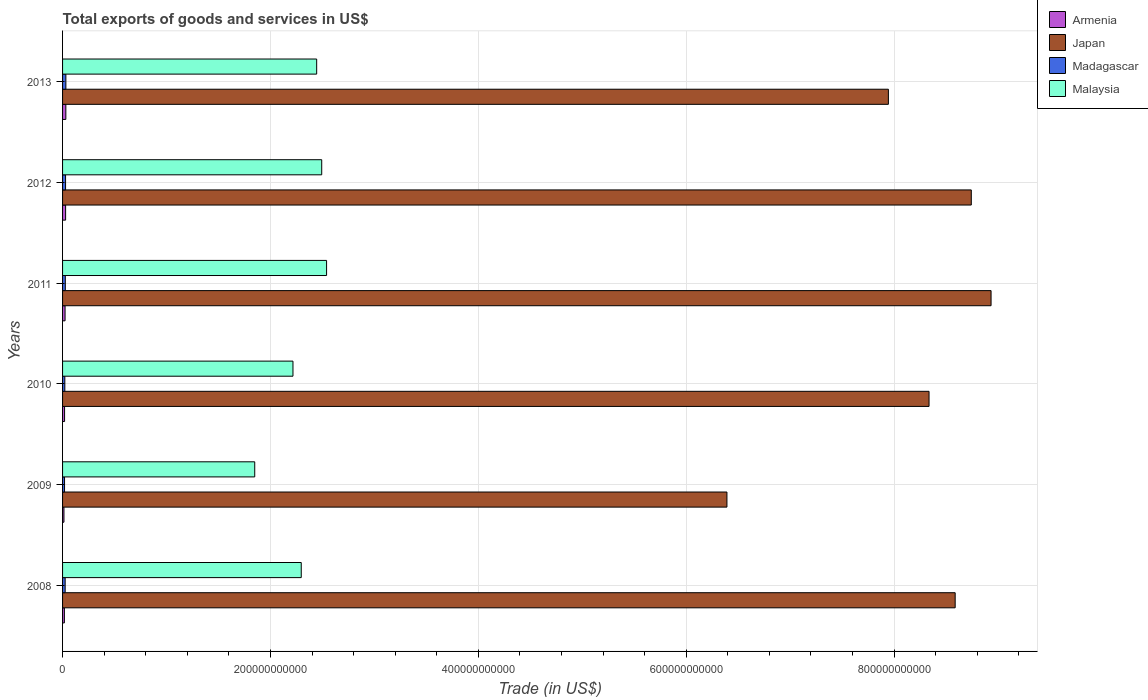How many different coloured bars are there?
Make the answer very short. 4. How many groups of bars are there?
Give a very brief answer. 6. Are the number of bars per tick equal to the number of legend labels?
Your response must be concise. Yes. How many bars are there on the 3rd tick from the top?
Offer a very short reply. 4. In how many cases, is the number of bars for a given year not equal to the number of legend labels?
Ensure brevity in your answer.  0. What is the total exports of goods and services in Malaysia in 2013?
Your answer should be compact. 2.44e+11. Across all years, what is the maximum total exports of goods and services in Armenia?
Ensure brevity in your answer.  3.15e+09. Across all years, what is the minimum total exports of goods and services in Malaysia?
Offer a terse response. 1.85e+11. In which year was the total exports of goods and services in Madagascar maximum?
Your answer should be very brief. 2013. In which year was the total exports of goods and services in Malaysia minimum?
Offer a terse response. 2009. What is the total total exports of goods and services in Malaysia in the graph?
Ensure brevity in your answer.  1.38e+12. What is the difference between the total exports of goods and services in Madagascar in 2008 and that in 2009?
Provide a short and direct response. 5.86e+08. What is the difference between the total exports of goods and services in Armenia in 2010 and the total exports of goods and services in Madagascar in 2011?
Provide a short and direct response. -7.17e+08. What is the average total exports of goods and services in Japan per year?
Keep it short and to the point. 8.16e+11. In the year 2008, what is the difference between the total exports of goods and services in Armenia and total exports of goods and services in Madagascar?
Make the answer very short. -7.44e+08. What is the ratio of the total exports of goods and services in Malaysia in 2008 to that in 2012?
Give a very brief answer. 0.92. Is the total exports of goods and services in Japan in 2011 less than that in 2013?
Offer a very short reply. No. What is the difference between the highest and the second highest total exports of goods and services in Armenia?
Ensure brevity in your answer.  2.27e+08. What is the difference between the highest and the lowest total exports of goods and services in Madagascar?
Your response must be concise. 1.28e+09. What does the 4th bar from the top in 2010 represents?
Keep it short and to the point. Armenia. What does the 3rd bar from the bottom in 2012 represents?
Provide a short and direct response. Madagascar. What is the difference between two consecutive major ticks on the X-axis?
Provide a short and direct response. 2.00e+11. Are the values on the major ticks of X-axis written in scientific E-notation?
Offer a very short reply. No. Does the graph contain any zero values?
Your answer should be very brief. No. Where does the legend appear in the graph?
Ensure brevity in your answer.  Top right. What is the title of the graph?
Ensure brevity in your answer.  Total exports of goods and services in US$. Does "Turkey" appear as one of the legend labels in the graph?
Make the answer very short. No. What is the label or title of the X-axis?
Offer a terse response. Trade (in US$). What is the label or title of the Y-axis?
Give a very brief answer. Years. What is the Trade (in US$) in Armenia in 2008?
Offer a terse response. 1.75e+09. What is the Trade (in US$) of Japan in 2008?
Your answer should be compact. 8.59e+11. What is the Trade (in US$) in Madagascar in 2008?
Provide a short and direct response. 2.50e+09. What is the Trade (in US$) of Malaysia in 2008?
Give a very brief answer. 2.30e+11. What is the Trade (in US$) of Armenia in 2009?
Your response must be concise. 1.34e+09. What is the Trade (in US$) of Japan in 2009?
Your response must be concise. 6.39e+11. What is the Trade (in US$) of Madagascar in 2009?
Ensure brevity in your answer.  1.91e+09. What is the Trade (in US$) of Malaysia in 2009?
Make the answer very short. 1.85e+11. What is the Trade (in US$) in Armenia in 2010?
Offer a terse response. 1.93e+09. What is the Trade (in US$) of Japan in 2010?
Give a very brief answer. 8.34e+11. What is the Trade (in US$) in Madagascar in 2010?
Provide a succinct answer. 2.18e+09. What is the Trade (in US$) of Malaysia in 2010?
Offer a terse response. 2.22e+11. What is the Trade (in US$) in Armenia in 2011?
Provide a short and direct response. 2.41e+09. What is the Trade (in US$) in Japan in 2011?
Your answer should be compact. 8.93e+11. What is the Trade (in US$) of Madagascar in 2011?
Provide a short and direct response. 2.65e+09. What is the Trade (in US$) of Malaysia in 2011?
Offer a terse response. 2.54e+11. What is the Trade (in US$) in Armenia in 2012?
Your response must be concise. 2.93e+09. What is the Trade (in US$) of Japan in 2012?
Your answer should be very brief. 8.74e+11. What is the Trade (in US$) of Madagascar in 2012?
Give a very brief answer. 2.88e+09. What is the Trade (in US$) in Malaysia in 2012?
Offer a very short reply. 2.49e+11. What is the Trade (in US$) in Armenia in 2013?
Provide a succinct answer. 3.15e+09. What is the Trade (in US$) of Japan in 2013?
Your answer should be very brief. 7.95e+11. What is the Trade (in US$) of Madagascar in 2013?
Make the answer very short. 3.19e+09. What is the Trade (in US$) in Malaysia in 2013?
Make the answer very short. 2.44e+11. Across all years, what is the maximum Trade (in US$) of Armenia?
Your answer should be very brief. 3.15e+09. Across all years, what is the maximum Trade (in US$) of Japan?
Offer a very short reply. 8.93e+11. Across all years, what is the maximum Trade (in US$) in Madagascar?
Make the answer very short. 3.19e+09. Across all years, what is the maximum Trade (in US$) in Malaysia?
Provide a short and direct response. 2.54e+11. Across all years, what is the minimum Trade (in US$) in Armenia?
Your answer should be compact. 1.34e+09. Across all years, what is the minimum Trade (in US$) of Japan?
Offer a very short reply. 6.39e+11. Across all years, what is the minimum Trade (in US$) of Madagascar?
Offer a very short reply. 1.91e+09. Across all years, what is the minimum Trade (in US$) of Malaysia?
Provide a succinct answer. 1.85e+11. What is the total Trade (in US$) in Armenia in the graph?
Give a very brief answer. 1.35e+1. What is the total Trade (in US$) of Japan in the graph?
Offer a terse response. 4.89e+12. What is the total Trade (in US$) in Madagascar in the graph?
Ensure brevity in your answer.  1.53e+1. What is the total Trade (in US$) in Malaysia in the graph?
Keep it short and to the point. 1.38e+12. What is the difference between the Trade (in US$) of Armenia in 2008 and that in 2009?
Provide a short and direct response. 4.17e+08. What is the difference between the Trade (in US$) of Japan in 2008 and that in 2009?
Ensure brevity in your answer.  2.20e+11. What is the difference between the Trade (in US$) in Madagascar in 2008 and that in 2009?
Provide a short and direct response. 5.86e+08. What is the difference between the Trade (in US$) in Malaysia in 2008 and that in 2009?
Give a very brief answer. 4.48e+1. What is the difference between the Trade (in US$) of Armenia in 2008 and that in 2010?
Provide a succinct answer. -1.74e+08. What is the difference between the Trade (in US$) of Japan in 2008 and that in 2010?
Provide a short and direct response. 2.51e+1. What is the difference between the Trade (in US$) of Madagascar in 2008 and that in 2010?
Your answer should be compact. 3.18e+08. What is the difference between the Trade (in US$) of Malaysia in 2008 and that in 2010?
Keep it short and to the point. 7.97e+09. What is the difference between the Trade (in US$) of Armenia in 2008 and that in 2011?
Offer a very short reply. -6.55e+08. What is the difference between the Trade (in US$) in Japan in 2008 and that in 2011?
Offer a terse response. -3.45e+1. What is the difference between the Trade (in US$) in Madagascar in 2008 and that in 2011?
Give a very brief answer. -1.47e+08. What is the difference between the Trade (in US$) of Malaysia in 2008 and that in 2011?
Your answer should be compact. -2.44e+1. What is the difference between the Trade (in US$) in Armenia in 2008 and that in 2012?
Provide a short and direct response. -1.17e+09. What is the difference between the Trade (in US$) of Japan in 2008 and that in 2012?
Your answer should be very brief. -1.55e+1. What is the difference between the Trade (in US$) of Madagascar in 2008 and that in 2012?
Ensure brevity in your answer.  -3.79e+08. What is the difference between the Trade (in US$) in Malaysia in 2008 and that in 2012?
Ensure brevity in your answer.  -1.97e+1. What is the difference between the Trade (in US$) of Armenia in 2008 and that in 2013?
Offer a very short reply. -1.40e+09. What is the difference between the Trade (in US$) of Japan in 2008 and that in 2013?
Provide a succinct answer. 6.43e+1. What is the difference between the Trade (in US$) of Madagascar in 2008 and that in 2013?
Make the answer very short. -6.93e+08. What is the difference between the Trade (in US$) of Malaysia in 2008 and that in 2013?
Make the answer very short. -1.48e+1. What is the difference between the Trade (in US$) of Armenia in 2009 and that in 2010?
Provide a short and direct response. -5.91e+08. What is the difference between the Trade (in US$) of Japan in 2009 and that in 2010?
Provide a succinct answer. -1.94e+11. What is the difference between the Trade (in US$) of Madagascar in 2009 and that in 2010?
Provide a succinct answer. -2.68e+08. What is the difference between the Trade (in US$) of Malaysia in 2009 and that in 2010?
Offer a terse response. -3.68e+1. What is the difference between the Trade (in US$) of Armenia in 2009 and that in 2011?
Your answer should be very brief. -1.07e+09. What is the difference between the Trade (in US$) of Japan in 2009 and that in 2011?
Offer a terse response. -2.54e+11. What is the difference between the Trade (in US$) in Madagascar in 2009 and that in 2011?
Make the answer very short. -7.33e+08. What is the difference between the Trade (in US$) of Malaysia in 2009 and that in 2011?
Provide a succinct answer. -6.91e+1. What is the difference between the Trade (in US$) in Armenia in 2009 and that in 2012?
Keep it short and to the point. -1.59e+09. What is the difference between the Trade (in US$) in Japan in 2009 and that in 2012?
Offer a terse response. -2.35e+11. What is the difference between the Trade (in US$) of Madagascar in 2009 and that in 2012?
Offer a very short reply. -9.65e+08. What is the difference between the Trade (in US$) of Malaysia in 2009 and that in 2012?
Make the answer very short. -6.45e+1. What is the difference between the Trade (in US$) in Armenia in 2009 and that in 2013?
Provide a short and direct response. -1.82e+09. What is the difference between the Trade (in US$) in Japan in 2009 and that in 2013?
Give a very brief answer. -1.55e+11. What is the difference between the Trade (in US$) in Madagascar in 2009 and that in 2013?
Provide a short and direct response. -1.28e+09. What is the difference between the Trade (in US$) of Malaysia in 2009 and that in 2013?
Offer a terse response. -5.96e+1. What is the difference between the Trade (in US$) in Armenia in 2010 and that in 2011?
Provide a short and direct response. -4.81e+08. What is the difference between the Trade (in US$) in Japan in 2010 and that in 2011?
Your response must be concise. -5.97e+1. What is the difference between the Trade (in US$) of Madagascar in 2010 and that in 2011?
Make the answer very short. -4.65e+08. What is the difference between the Trade (in US$) of Malaysia in 2010 and that in 2011?
Keep it short and to the point. -3.23e+1. What is the difference between the Trade (in US$) of Armenia in 2010 and that in 2012?
Provide a short and direct response. -9.98e+08. What is the difference between the Trade (in US$) of Japan in 2010 and that in 2012?
Give a very brief answer. -4.06e+1. What is the difference between the Trade (in US$) in Madagascar in 2010 and that in 2012?
Offer a terse response. -6.98e+08. What is the difference between the Trade (in US$) in Malaysia in 2010 and that in 2012?
Provide a succinct answer. -2.77e+1. What is the difference between the Trade (in US$) of Armenia in 2010 and that in 2013?
Give a very brief answer. -1.23e+09. What is the difference between the Trade (in US$) in Japan in 2010 and that in 2013?
Provide a succinct answer. 3.91e+1. What is the difference between the Trade (in US$) in Madagascar in 2010 and that in 2013?
Give a very brief answer. -1.01e+09. What is the difference between the Trade (in US$) in Malaysia in 2010 and that in 2013?
Your answer should be very brief. -2.28e+1. What is the difference between the Trade (in US$) of Armenia in 2011 and that in 2012?
Provide a short and direct response. -5.18e+08. What is the difference between the Trade (in US$) in Japan in 2011 and that in 2012?
Provide a short and direct response. 1.90e+1. What is the difference between the Trade (in US$) of Madagascar in 2011 and that in 2012?
Ensure brevity in your answer.  -2.32e+08. What is the difference between the Trade (in US$) of Malaysia in 2011 and that in 2012?
Offer a very short reply. 4.67e+09. What is the difference between the Trade (in US$) of Armenia in 2011 and that in 2013?
Ensure brevity in your answer.  -7.45e+08. What is the difference between the Trade (in US$) of Japan in 2011 and that in 2013?
Your answer should be very brief. 9.88e+1. What is the difference between the Trade (in US$) of Madagascar in 2011 and that in 2013?
Provide a succinct answer. -5.46e+08. What is the difference between the Trade (in US$) in Malaysia in 2011 and that in 2013?
Give a very brief answer. 9.53e+09. What is the difference between the Trade (in US$) of Armenia in 2012 and that in 2013?
Offer a terse response. -2.27e+08. What is the difference between the Trade (in US$) of Japan in 2012 and that in 2013?
Provide a succinct answer. 7.98e+1. What is the difference between the Trade (in US$) of Madagascar in 2012 and that in 2013?
Ensure brevity in your answer.  -3.13e+08. What is the difference between the Trade (in US$) in Malaysia in 2012 and that in 2013?
Ensure brevity in your answer.  4.86e+09. What is the difference between the Trade (in US$) of Armenia in 2008 and the Trade (in US$) of Japan in 2009?
Your answer should be very brief. -6.37e+11. What is the difference between the Trade (in US$) in Armenia in 2008 and the Trade (in US$) in Madagascar in 2009?
Give a very brief answer. -1.58e+08. What is the difference between the Trade (in US$) in Armenia in 2008 and the Trade (in US$) in Malaysia in 2009?
Your answer should be very brief. -1.83e+11. What is the difference between the Trade (in US$) in Japan in 2008 and the Trade (in US$) in Madagascar in 2009?
Make the answer very short. 8.57e+11. What is the difference between the Trade (in US$) in Japan in 2008 and the Trade (in US$) in Malaysia in 2009?
Keep it short and to the point. 6.74e+11. What is the difference between the Trade (in US$) of Madagascar in 2008 and the Trade (in US$) of Malaysia in 2009?
Your answer should be very brief. -1.82e+11. What is the difference between the Trade (in US$) of Armenia in 2008 and the Trade (in US$) of Japan in 2010?
Provide a succinct answer. -8.32e+11. What is the difference between the Trade (in US$) of Armenia in 2008 and the Trade (in US$) of Madagascar in 2010?
Your answer should be compact. -4.25e+08. What is the difference between the Trade (in US$) of Armenia in 2008 and the Trade (in US$) of Malaysia in 2010?
Provide a succinct answer. -2.20e+11. What is the difference between the Trade (in US$) in Japan in 2008 and the Trade (in US$) in Madagascar in 2010?
Your answer should be very brief. 8.57e+11. What is the difference between the Trade (in US$) in Japan in 2008 and the Trade (in US$) in Malaysia in 2010?
Give a very brief answer. 6.37e+11. What is the difference between the Trade (in US$) in Madagascar in 2008 and the Trade (in US$) in Malaysia in 2010?
Your answer should be very brief. -2.19e+11. What is the difference between the Trade (in US$) of Armenia in 2008 and the Trade (in US$) of Japan in 2011?
Your answer should be very brief. -8.92e+11. What is the difference between the Trade (in US$) of Armenia in 2008 and the Trade (in US$) of Madagascar in 2011?
Provide a short and direct response. -8.91e+08. What is the difference between the Trade (in US$) of Armenia in 2008 and the Trade (in US$) of Malaysia in 2011?
Make the answer very short. -2.52e+11. What is the difference between the Trade (in US$) of Japan in 2008 and the Trade (in US$) of Madagascar in 2011?
Provide a succinct answer. 8.56e+11. What is the difference between the Trade (in US$) of Japan in 2008 and the Trade (in US$) of Malaysia in 2011?
Offer a very short reply. 6.05e+11. What is the difference between the Trade (in US$) in Madagascar in 2008 and the Trade (in US$) in Malaysia in 2011?
Make the answer very short. -2.52e+11. What is the difference between the Trade (in US$) in Armenia in 2008 and the Trade (in US$) in Japan in 2012?
Your answer should be compact. -8.73e+11. What is the difference between the Trade (in US$) in Armenia in 2008 and the Trade (in US$) in Madagascar in 2012?
Ensure brevity in your answer.  -1.12e+09. What is the difference between the Trade (in US$) of Armenia in 2008 and the Trade (in US$) of Malaysia in 2012?
Your response must be concise. -2.48e+11. What is the difference between the Trade (in US$) in Japan in 2008 and the Trade (in US$) in Madagascar in 2012?
Provide a succinct answer. 8.56e+11. What is the difference between the Trade (in US$) of Japan in 2008 and the Trade (in US$) of Malaysia in 2012?
Your answer should be very brief. 6.09e+11. What is the difference between the Trade (in US$) of Madagascar in 2008 and the Trade (in US$) of Malaysia in 2012?
Your answer should be compact. -2.47e+11. What is the difference between the Trade (in US$) of Armenia in 2008 and the Trade (in US$) of Japan in 2013?
Offer a very short reply. -7.93e+11. What is the difference between the Trade (in US$) of Armenia in 2008 and the Trade (in US$) of Madagascar in 2013?
Provide a short and direct response. -1.44e+09. What is the difference between the Trade (in US$) in Armenia in 2008 and the Trade (in US$) in Malaysia in 2013?
Make the answer very short. -2.43e+11. What is the difference between the Trade (in US$) in Japan in 2008 and the Trade (in US$) in Madagascar in 2013?
Your answer should be compact. 8.56e+11. What is the difference between the Trade (in US$) of Japan in 2008 and the Trade (in US$) of Malaysia in 2013?
Your answer should be very brief. 6.14e+11. What is the difference between the Trade (in US$) of Madagascar in 2008 and the Trade (in US$) of Malaysia in 2013?
Offer a very short reply. -2.42e+11. What is the difference between the Trade (in US$) of Armenia in 2009 and the Trade (in US$) of Japan in 2010?
Your response must be concise. -8.32e+11. What is the difference between the Trade (in US$) in Armenia in 2009 and the Trade (in US$) in Madagascar in 2010?
Your answer should be compact. -8.42e+08. What is the difference between the Trade (in US$) of Armenia in 2009 and the Trade (in US$) of Malaysia in 2010?
Make the answer very short. -2.20e+11. What is the difference between the Trade (in US$) in Japan in 2009 and the Trade (in US$) in Madagascar in 2010?
Offer a very short reply. 6.37e+11. What is the difference between the Trade (in US$) of Japan in 2009 and the Trade (in US$) of Malaysia in 2010?
Your response must be concise. 4.18e+11. What is the difference between the Trade (in US$) in Madagascar in 2009 and the Trade (in US$) in Malaysia in 2010?
Provide a short and direct response. -2.20e+11. What is the difference between the Trade (in US$) in Armenia in 2009 and the Trade (in US$) in Japan in 2011?
Provide a succinct answer. -8.92e+11. What is the difference between the Trade (in US$) of Armenia in 2009 and the Trade (in US$) of Madagascar in 2011?
Ensure brevity in your answer.  -1.31e+09. What is the difference between the Trade (in US$) in Armenia in 2009 and the Trade (in US$) in Malaysia in 2011?
Keep it short and to the point. -2.53e+11. What is the difference between the Trade (in US$) of Japan in 2009 and the Trade (in US$) of Madagascar in 2011?
Offer a very short reply. 6.37e+11. What is the difference between the Trade (in US$) in Japan in 2009 and the Trade (in US$) in Malaysia in 2011?
Offer a terse response. 3.85e+11. What is the difference between the Trade (in US$) in Madagascar in 2009 and the Trade (in US$) in Malaysia in 2011?
Your answer should be very brief. -2.52e+11. What is the difference between the Trade (in US$) in Armenia in 2009 and the Trade (in US$) in Japan in 2012?
Offer a very short reply. -8.73e+11. What is the difference between the Trade (in US$) of Armenia in 2009 and the Trade (in US$) of Madagascar in 2012?
Your answer should be very brief. -1.54e+09. What is the difference between the Trade (in US$) in Armenia in 2009 and the Trade (in US$) in Malaysia in 2012?
Ensure brevity in your answer.  -2.48e+11. What is the difference between the Trade (in US$) of Japan in 2009 and the Trade (in US$) of Madagascar in 2012?
Your response must be concise. 6.36e+11. What is the difference between the Trade (in US$) of Japan in 2009 and the Trade (in US$) of Malaysia in 2012?
Give a very brief answer. 3.90e+11. What is the difference between the Trade (in US$) of Madagascar in 2009 and the Trade (in US$) of Malaysia in 2012?
Offer a very short reply. -2.47e+11. What is the difference between the Trade (in US$) in Armenia in 2009 and the Trade (in US$) in Japan in 2013?
Offer a terse response. -7.93e+11. What is the difference between the Trade (in US$) in Armenia in 2009 and the Trade (in US$) in Madagascar in 2013?
Your response must be concise. -1.85e+09. What is the difference between the Trade (in US$) of Armenia in 2009 and the Trade (in US$) of Malaysia in 2013?
Ensure brevity in your answer.  -2.43e+11. What is the difference between the Trade (in US$) of Japan in 2009 and the Trade (in US$) of Madagascar in 2013?
Provide a succinct answer. 6.36e+11. What is the difference between the Trade (in US$) in Japan in 2009 and the Trade (in US$) in Malaysia in 2013?
Provide a succinct answer. 3.95e+11. What is the difference between the Trade (in US$) of Madagascar in 2009 and the Trade (in US$) of Malaysia in 2013?
Ensure brevity in your answer.  -2.43e+11. What is the difference between the Trade (in US$) of Armenia in 2010 and the Trade (in US$) of Japan in 2011?
Offer a very short reply. -8.91e+11. What is the difference between the Trade (in US$) in Armenia in 2010 and the Trade (in US$) in Madagascar in 2011?
Give a very brief answer. -7.17e+08. What is the difference between the Trade (in US$) in Armenia in 2010 and the Trade (in US$) in Malaysia in 2011?
Offer a terse response. -2.52e+11. What is the difference between the Trade (in US$) of Japan in 2010 and the Trade (in US$) of Madagascar in 2011?
Keep it short and to the point. 8.31e+11. What is the difference between the Trade (in US$) of Japan in 2010 and the Trade (in US$) of Malaysia in 2011?
Your response must be concise. 5.80e+11. What is the difference between the Trade (in US$) of Madagascar in 2010 and the Trade (in US$) of Malaysia in 2011?
Give a very brief answer. -2.52e+11. What is the difference between the Trade (in US$) in Armenia in 2010 and the Trade (in US$) in Japan in 2012?
Make the answer very short. -8.72e+11. What is the difference between the Trade (in US$) of Armenia in 2010 and the Trade (in US$) of Madagascar in 2012?
Provide a succinct answer. -9.49e+08. What is the difference between the Trade (in US$) of Armenia in 2010 and the Trade (in US$) of Malaysia in 2012?
Keep it short and to the point. -2.47e+11. What is the difference between the Trade (in US$) in Japan in 2010 and the Trade (in US$) in Madagascar in 2012?
Offer a terse response. 8.31e+11. What is the difference between the Trade (in US$) in Japan in 2010 and the Trade (in US$) in Malaysia in 2012?
Provide a succinct answer. 5.84e+11. What is the difference between the Trade (in US$) of Madagascar in 2010 and the Trade (in US$) of Malaysia in 2012?
Your answer should be very brief. -2.47e+11. What is the difference between the Trade (in US$) in Armenia in 2010 and the Trade (in US$) in Japan in 2013?
Your response must be concise. -7.93e+11. What is the difference between the Trade (in US$) of Armenia in 2010 and the Trade (in US$) of Madagascar in 2013?
Offer a terse response. -1.26e+09. What is the difference between the Trade (in US$) of Armenia in 2010 and the Trade (in US$) of Malaysia in 2013?
Your response must be concise. -2.43e+11. What is the difference between the Trade (in US$) in Japan in 2010 and the Trade (in US$) in Madagascar in 2013?
Keep it short and to the point. 8.31e+11. What is the difference between the Trade (in US$) of Japan in 2010 and the Trade (in US$) of Malaysia in 2013?
Offer a terse response. 5.89e+11. What is the difference between the Trade (in US$) in Madagascar in 2010 and the Trade (in US$) in Malaysia in 2013?
Make the answer very short. -2.42e+11. What is the difference between the Trade (in US$) of Armenia in 2011 and the Trade (in US$) of Japan in 2012?
Your response must be concise. -8.72e+11. What is the difference between the Trade (in US$) of Armenia in 2011 and the Trade (in US$) of Madagascar in 2012?
Make the answer very short. -4.68e+08. What is the difference between the Trade (in US$) of Armenia in 2011 and the Trade (in US$) of Malaysia in 2012?
Offer a very short reply. -2.47e+11. What is the difference between the Trade (in US$) of Japan in 2011 and the Trade (in US$) of Madagascar in 2012?
Provide a succinct answer. 8.91e+11. What is the difference between the Trade (in US$) in Japan in 2011 and the Trade (in US$) in Malaysia in 2012?
Provide a succinct answer. 6.44e+11. What is the difference between the Trade (in US$) of Madagascar in 2011 and the Trade (in US$) of Malaysia in 2012?
Your answer should be compact. -2.47e+11. What is the difference between the Trade (in US$) of Armenia in 2011 and the Trade (in US$) of Japan in 2013?
Provide a short and direct response. -7.92e+11. What is the difference between the Trade (in US$) of Armenia in 2011 and the Trade (in US$) of Madagascar in 2013?
Provide a succinct answer. -7.82e+08. What is the difference between the Trade (in US$) of Armenia in 2011 and the Trade (in US$) of Malaysia in 2013?
Provide a short and direct response. -2.42e+11. What is the difference between the Trade (in US$) in Japan in 2011 and the Trade (in US$) in Madagascar in 2013?
Give a very brief answer. 8.90e+11. What is the difference between the Trade (in US$) of Japan in 2011 and the Trade (in US$) of Malaysia in 2013?
Offer a very short reply. 6.49e+11. What is the difference between the Trade (in US$) of Madagascar in 2011 and the Trade (in US$) of Malaysia in 2013?
Your answer should be compact. -2.42e+11. What is the difference between the Trade (in US$) of Armenia in 2012 and the Trade (in US$) of Japan in 2013?
Make the answer very short. -7.92e+11. What is the difference between the Trade (in US$) of Armenia in 2012 and the Trade (in US$) of Madagascar in 2013?
Your answer should be compact. -2.64e+08. What is the difference between the Trade (in US$) of Armenia in 2012 and the Trade (in US$) of Malaysia in 2013?
Offer a very short reply. -2.42e+11. What is the difference between the Trade (in US$) in Japan in 2012 and the Trade (in US$) in Madagascar in 2013?
Provide a succinct answer. 8.71e+11. What is the difference between the Trade (in US$) in Japan in 2012 and the Trade (in US$) in Malaysia in 2013?
Give a very brief answer. 6.30e+11. What is the difference between the Trade (in US$) of Madagascar in 2012 and the Trade (in US$) of Malaysia in 2013?
Offer a terse response. -2.42e+11. What is the average Trade (in US$) of Armenia per year?
Keep it short and to the point. 2.25e+09. What is the average Trade (in US$) in Japan per year?
Give a very brief answer. 8.16e+11. What is the average Trade (in US$) in Madagascar per year?
Offer a very short reply. 2.55e+09. What is the average Trade (in US$) in Malaysia per year?
Offer a very short reply. 2.31e+11. In the year 2008, what is the difference between the Trade (in US$) of Armenia and Trade (in US$) of Japan?
Ensure brevity in your answer.  -8.57e+11. In the year 2008, what is the difference between the Trade (in US$) of Armenia and Trade (in US$) of Madagascar?
Keep it short and to the point. -7.44e+08. In the year 2008, what is the difference between the Trade (in US$) in Armenia and Trade (in US$) in Malaysia?
Your answer should be compact. -2.28e+11. In the year 2008, what is the difference between the Trade (in US$) of Japan and Trade (in US$) of Madagascar?
Keep it short and to the point. 8.56e+11. In the year 2008, what is the difference between the Trade (in US$) of Japan and Trade (in US$) of Malaysia?
Give a very brief answer. 6.29e+11. In the year 2008, what is the difference between the Trade (in US$) in Madagascar and Trade (in US$) in Malaysia?
Ensure brevity in your answer.  -2.27e+11. In the year 2009, what is the difference between the Trade (in US$) of Armenia and Trade (in US$) of Japan?
Your answer should be compact. -6.38e+11. In the year 2009, what is the difference between the Trade (in US$) in Armenia and Trade (in US$) in Madagascar?
Give a very brief answer. -5.74e+08. In the year 2009, what is the difference between the Trade (in US$) in Armenia and Trade (in US$) in Malaysia?
Your answer should be very brief. -1.84e+11. In the year 2009, what is the difference between the Trade (in US$) in Japan and Trade (in US$) in Madagascar?
Give a very brief answer. 6.37e+11. In the year 2009, what is the difference between the Trade (in US$) of Japan and Trade (in US$) of Malaysia?
Provide a succinct answer. 4.54e+11. In the year 2009, what is the difference between the Trade (in US$) in Madagascar and Trade (in US$) in Malaysia?
Keep it short and to the point. -1.83e+11. In the year 2010, what is the difference between the Trade (in US$) in Armenia and Trade (in US$) in Japan?
Keep it short and to the point. -8.32e+11. In the year 2010, what is the difference between the Trade (in US$) in Armenia and Trade (in US$) in Madagascar?
Offer a very short reply. -2.51e+08. In the year 2010, what is the difference between the Trade (in US$) of Armenia and Trade (in US$) of Malaysia?
Make the answer very short. -2.20e+11. In the year 2010, what is the difference between the Trade (in US$) of Japan and Trade (in US$) of Madagascar?
Make the answer very short. 8.32e+11. In the year 2010, what is the difference between the Trade (in US$) of Japan and Trade (in US$) of Malaysia?
Offer a very short reply. 6.12e+11. In the year 2010, what is the difference between the Trade (in US$) of Madagascar and Trade (in US$) of Malaysia?
Keep it short and to the point. -2.20e+11. In the year 2011, what is the difference between the Trade (in US$) of Armenia and Trade (in US$) of Japan?
Ensure brevity in your answer.  -8.91e+11. In the year 2011, what is the difference between the Trade (in US$) of Armenia and Trade (in US$) of Madagascar?
Provide a succinct answer. -2.36e+08. In the year 2011, what is the difference between the Trade (in US$) in Armenia and Trade (in US$) in Malaysia?
Keep it short and to the point. -2.52e+11. In the year 2011, what is the difference between the Trade (in US$) of Japan and Trade (in US$) of Madagascar?
Offer a very short reply. 8.91e+11. In the year 2011, what is the difference between the Trade (in US$) of Japan and Trade (in US$) of Malaysia?
Offer a very short reply. 6.39e+11. In the year 2011, what is the difference between the Trade (in US$) of Madagascar and Trade (in US$) of Malaysia?
Ensure brevity in your answer.  -2.51e+11. In the year 2012, what is the difference between the Trade (in US$) of Armenia and Trade (in US$) of Japan?
Give a very brief answer. -8.71e+11. In the year 2012, what is the difference between the Trade (in US$) in Armenia and Trade (in US$) in Madagascar?
Provide a succinct answer. 4.97e+07. In the year 2012, what is the difference between the Trade (in US$) in Armenia and Trade (in US$) in Malaysia?
Provide a succinct answer. -2.46e+11. In the year 2012, what is the difference between the Trade (in US$) in Japan and Trade (in US$) in Madagascar?
Ensure brevity in your answer.  8.71e+11. In the year 2012, what is the difference between the Trade (in US$) of Japan and Trade (in US$) of Malaysia?
Offer a very short reply. 6.25e+11. In the year 2012, what is the difference between the Trade (in US$) of Madagascar and Trade (in US$) of Malaysia?
Your response must be concise. -2.46e+11. In the year 2013, what is the difference between the Trade (in US$) of Armenia and Trade (in US$) of Japan?
Your answer should be very brief. -7.91e+11. In the year 2013, what is the difference between the Trade (in US$) in Armenia and Trade (in US$) in Madagascar?
Give a very brief answer. -3.72e+07. In the year 2013, what is the difference between the Trade (in US$) in Armenia and Trade (in US$) in Malaysia?
Provide a succinct answer. -2.41e+11. In the year 2013, what is the difference between the Trade (in US$) of Japan and Trade (in US$) of Madagascar?
Provide a short and direct response. 7.91e+11. In the year 2013, what is the difference between the Trade (in US$) of Japan and Trade (in US$) of Malaysia?
Give a very brief answer. 5.50e+11. In the year 2013, what is the difference between the Trade (in US$) in Madagascar and Trade (in US$) in Malaysia?
Give a very brief answer. -2.41e+11. What is the ratio of the Trade (in US$) in Armenia in 2008 to that in 2009?
Ensure brevity in your answer.  1.31. What is the ratio of the Trade (in US$) of Japan in 2008 to that in 2009?
Offer a very short reply. 1.34. What is the ratio of the Trade (in US$) in Madagascar in 2008 to that in 2009?
Make the answer very short. 1.31. What is the ratio of the Trade (in US$) of Malaysia in 2008 to that in 2009?
Offer a very short reply. 1.24. What is the ratio of the Trade (in US$) in Armenia in 2008 to that in 2010?
Offer a very short reply. 0.91. What is the ratio of the Trade (in US$) in Japan in 2008 to that in 2010?
Give a very brief answer. 1.03. What is the ratio of the Trade (in US$) in Madagascar in 2008 to that in 2010?
Ensure brevity in your answer.  1.15. What is the ratio of the Trade (in US$) in Malaysia in 2008 to that in 2010?
Make the answer very short. 1.04. What is the ratio of the Trade (in US$) of Armenia in 2008 to that in 2011?
Keep it short and to the point. 0.73. What is the ratio of the Trade (in US$) of Japan in 2008 to that in 2011?
Offer a terse response. 0.96. What is the ratio of the Trade (in US$) of Madagascar in 2008 to that in 2011?
Your answer should be very brief. 0.94. What is the ratio of the Trade (in US$) of Malaysia in 2008 to that in 2011?
Provide a succinct answer. 0.9. What is the ratio of the Trade (in US$) in Armenia in 2008 to that in 2012?
Ensure brevity in your answer.  0.6. What is the ratio of the Trade (in US$) in Japan in 2008 to that in 2012?
Make the answer very short. 0.98. What is the ratio of the Trade (in US$) in Madagascar in 2008 to that in 2012?
Make the answer very short. 0.87. What is the ratio of the Trade (in US$) of Malaysia in 2008 to that in 2012?
Your response must be concise. 0.92. What is the ratio of the Trade (in US$) of Armenia in 2008 to that in 2013?
Keep it short and to the point. 0.56. What is the ratio of the Trade (in US$) in Japan in 2008 to that in 2013?
Make the answer very short. 1.08. What is the ratio of the Trade (in US$) of Madagascar in 2008 to that in 2013?
Give a very brief answer. 0.78. What is the ratio of the Trade (in US$) of Malaysia in 2008 to that in 2013?
Offer a terse response. 0.94. What is the ratio of the Trade (in US$) of Armenia in 2009 to that in 2010?
Offer a very short reply. 0.69. What is the ratio of the Trade (in US$) of Japan in 2009 to that in 2010?
Ensure brevity in your answer.  0.77. What is the ratio of the Trade (in US$) in Madagascar in 2009 to that in 2010?
Give a very brief answer. 0.88. What is the ratio of the Trade (in US$) in Malaysia in 2009 to that in 2010?
Offer a very short reply. 0.83. What is the ratio of the Trade (in US$) of Armenia in 2009 to that in 2011?
Provide a short and direct response. 0.56. What is the ratio of the Trade (in US$) of Japan in 2009 to that in 2011?
Your answer should be very brief. 0.72. What is the ratio of the Trade (in US$) in Madagascar in 2009 to that in 2011?
Offer a terse response. 0.72. What is the ratio of the Trade (in US$) in Malaysia in 2009 to that in 2011?
Your answer should be compact. 0.73. What is the ratio of the Trade (in US$) in Armenia in 2009 to that in 2012?
Provide a short and direct response. 0.46. What is the ratio of the Trade (in US$) of Japan in 2009 to that in 2012?
Keep it short and to the point. 0.73. What is the ratio of the Trade (in US$) of Madagascar in 2009 to that in 2012?
Provide a short and direct response. 0.66. What is the ratio of the Trade (in US$) of Malaysia in 2009 to that in 2012?
Provide a succinct answer. 0.74. What is the ratio of the Trade (in US$) in Armenia in 2009 to that in 2013?
Make the answer very short. 0.42. What is the ratio of the Trade (in US$) in Japan in 2009 to that in 2013?
Ensure brevity in your answer.  0.8. What is the ratio of the Trade (in US$) in Madagascar in 2009 to that in 2013?
Your answer should be compact. 0.6. What is the ratio of the Trade (in US$) of Malaysia in 2009 to that in 2013?
Your answer should be very brief. 0.76. What is the ratio of the Trade (in US$) in Armenia in 2010 to that in 2011?
Keep it short and to the point. 0.8. What is the ratio of the Trade (in US$) in Japan in 2010 to that in 2011?
Provide a short and direct response. 0.93. What is the ratio of the Trade (in US$) of Madagascar in 2010 to that in 2011?
Your answer should be compact. 0.82. What is the ratio of the Trade (in US$) in Malaysia in 2010 to that in 2011?
Your answer should be compact. 0.87. What is the ratio of the Trade (in US$) in Armenia in 2010 to that in 2012?
Give a very brief answer. 0.66. What is the ratio of the Trade (in US$) in Japan in 2010 to that in 2012?
Your answer should be compact. 0.95. What is the ratio of the Trade (in US$) of Madagascar in 2010 to that in 2012?
Provide a short and direct response. 0.76. What is the ratio of the Trade (in US$) of Malaysia in 2010 to that in 2012?
Your answer should be very brief. 0.89. What is the ratio of the Trade (in US$) of Armenia in 2010 to that in 2013?
Offer a very short reply. 0.61. What is the ratio of the Trade (in US$) in Japan in 2010 to that in 2013?
Offer a terse response. 1.05. What is the ratio of the Trade (in US$) in Madagascar in 2010 to that in 2013?
Provide a short and direct response. 0.68. What is the ratio of the Trade (in US$) in Malaysia in 2010 to that in 2013?
Make the answer very short. 0.91. What is the ratio of the Trade (in US$) of Armenia in 2011 to that in 2012?
Keep it short and to the point. 0.82. What is the ratio of the Trade (in US$) in Japan in 2011 to that in 2012?
Offer a terse response. 1.02. What is the ratio of the Trade (in US$) in Madagascar in 2011 to that in 2012?
Your answer should be very brief. 0.92. What is the ratio of the Trade (in US$) of Malaysia in 2011 to that in 2012?
Provide a succinct answer. 1.02. What is the ratio of the Trade (in US$) in Armenia in 2011 to that in 2013?
Your answer should be compact. 0.76. What is the ratio of the Trade (in US$) of Japan in 2011 to that in 2013?
Provide a short and direct response. 1.12. What is the ratio of the Trade (in US$) in Madagascar in 2011 to that in 2013?
Provide a short and direct response. 0.83. What is the ratio of the Trade (in US$) in Malaysia in 2011 to that in 2013?
Offer a terse response. 1.04. What is the ratio of the Trade (in US$) in Armenia in 2012 to that in 2013?
Provide a succinct answer. 0.93. What is the ratio of the Trade (in US$) in Japan in 2012 to that in 2013?
Your answer should be compact. 1.1. What is the ratio of the Trade (in US$) in Madagascar in 2012 to that in 2013?
Ensure brevity in your answer.  0.9. What is the ratio of the Trade (in US$) of Malaysia in 2012 to that in 2013?
Your response must be concise. 1.02. What is the difference between the highest and the second highest Trade (in US$) in Armenia?
Your answer should be compact. 2.27e+08. What is the difference between the highest and the second highest Trade (in US$) in Japan?
Your response must be concise. 1.90e+1. What is the difference between the highest and the second highest Trade (in US$) of Madagascar?
Make the answer very short. 3.13e+08. What is the difference between the highest and the second highest Trade (in US$) of Malaysia?
Ensure brevity in your answer.  4.67e+09. What is the difference between the highest and the lowest Trade (in US$) of Armenia?
Offer a very short reply. 1.82e+09. What is the difference between the highest and the lowest Trade (in US$) of Japan?
Offer a very short reply. 2.54e+11. What is the difference between the highest and the lowest Trade (in US$) of Madagascar?
Ensure brevity in your answer.  1.28e+09. What is the difference between the highest and the lowest Trade (in US$) of Malaysia?
Provide a short and direct response. 6.91e+1. 